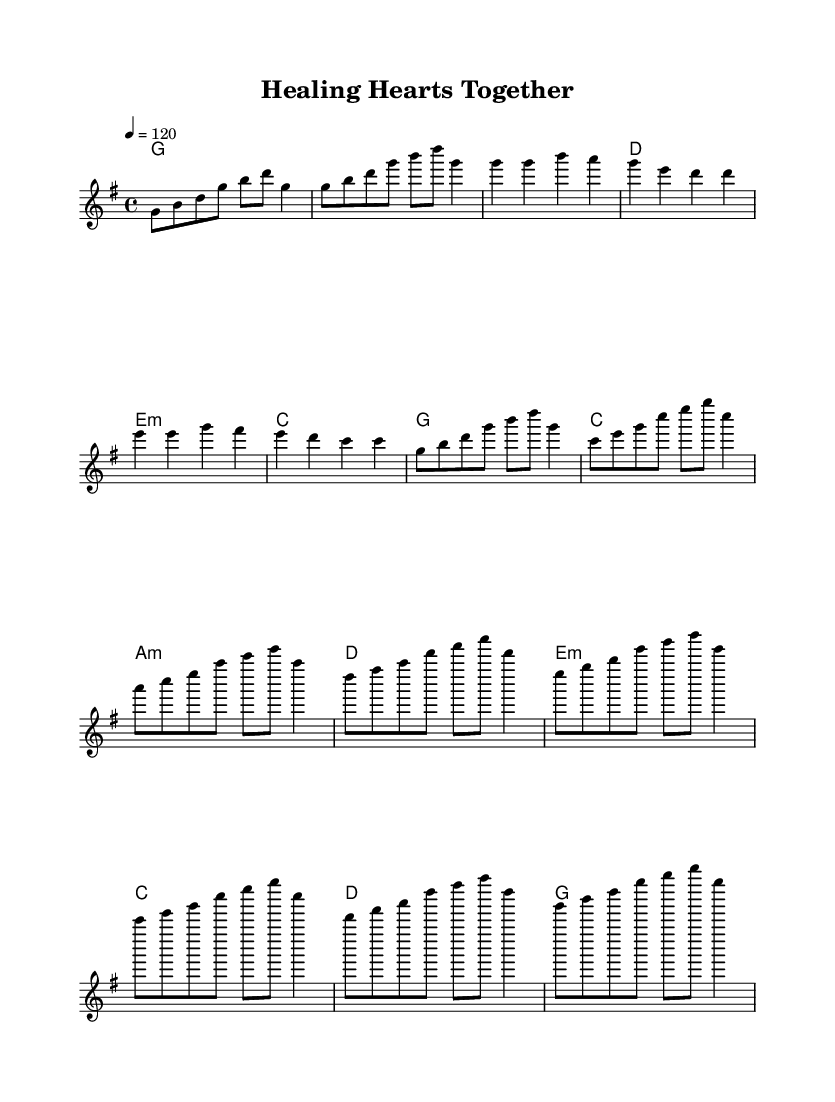What is the key signature of this music? The key signature is indicated at the beginning of the score, showing one sharp, which indicates that it's in G major.
Answer: G major What is the time signature of this music? The time signature is found at the beginning of the score, indicating a 4/4 time signature, meaning there are four beats in each measure.
Answer: 4/4 What is the tempo marking for this piece? The tempo marking is specified as "4 = 120," which means that one beat is equal to 120 beats per minute.
Answer: 120 How many measures are there in the chorus section? By analyzing the sheet music, the chorus section has four measures, which can be counted based on the chord progressions noted.
Answer: 4 What is the harmonic progression for the chorus? The harmony for the chorus is a sequence of chords: G, C, A minor, D, reflecting the commonly used chord progression in K-Pop songs for a catchy and uplifting feel.
Answer: G, C, A minor, D What kind of emotional theme does this piece convey? The title "Healing Hearts Together" suggests themes of positivity and unity, aligning with the K-Pop focus on mental health awareness and charitable causes.
Answer: Healing Hearts Together 